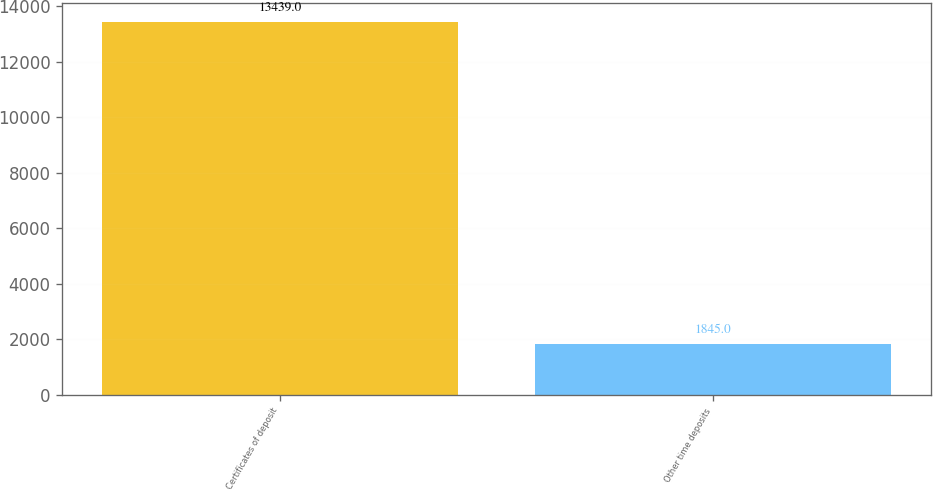Convert chart. <chart><loc_0><loc_0><loc_500><loc_500><bar_chart><fcel>Certificates of deposit<fcel>Other time deposits<nl><fcel>13439<fcel>1845<nl></chart> 